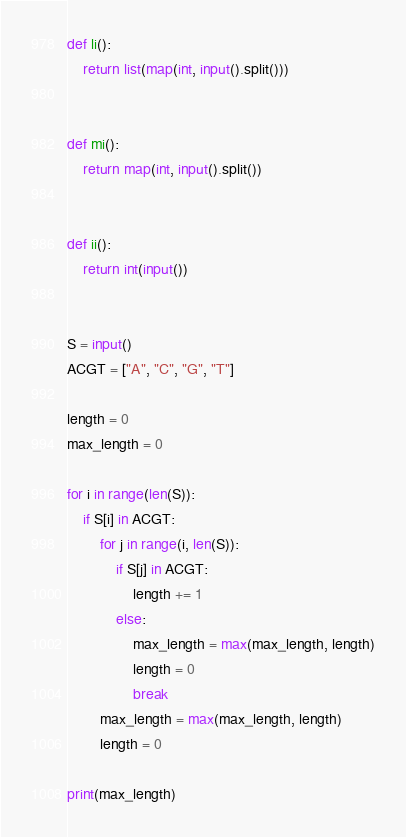Convert code to text. <code><loc_0><loc_0><loc_500><loc_500><_Python_>def li():
    return list(map(int, input().split()))


def mi():
    return map(int, input().split())


def ii():
    return int(input())


S = input()
ACGT = ["A", "C", "G", "T"]

length = 0
max_length = 0

for i in range(len(S)):
    if S[i] in ACGT:
        for j in range(i, len(S)):
            if S[j] in ACGT:
                length += 1
            else:
                max_length = max(max_length, length)
                length = 0
                break
        max_length = max(max_length, length)
        length = 0

print(max_length)
</code> 